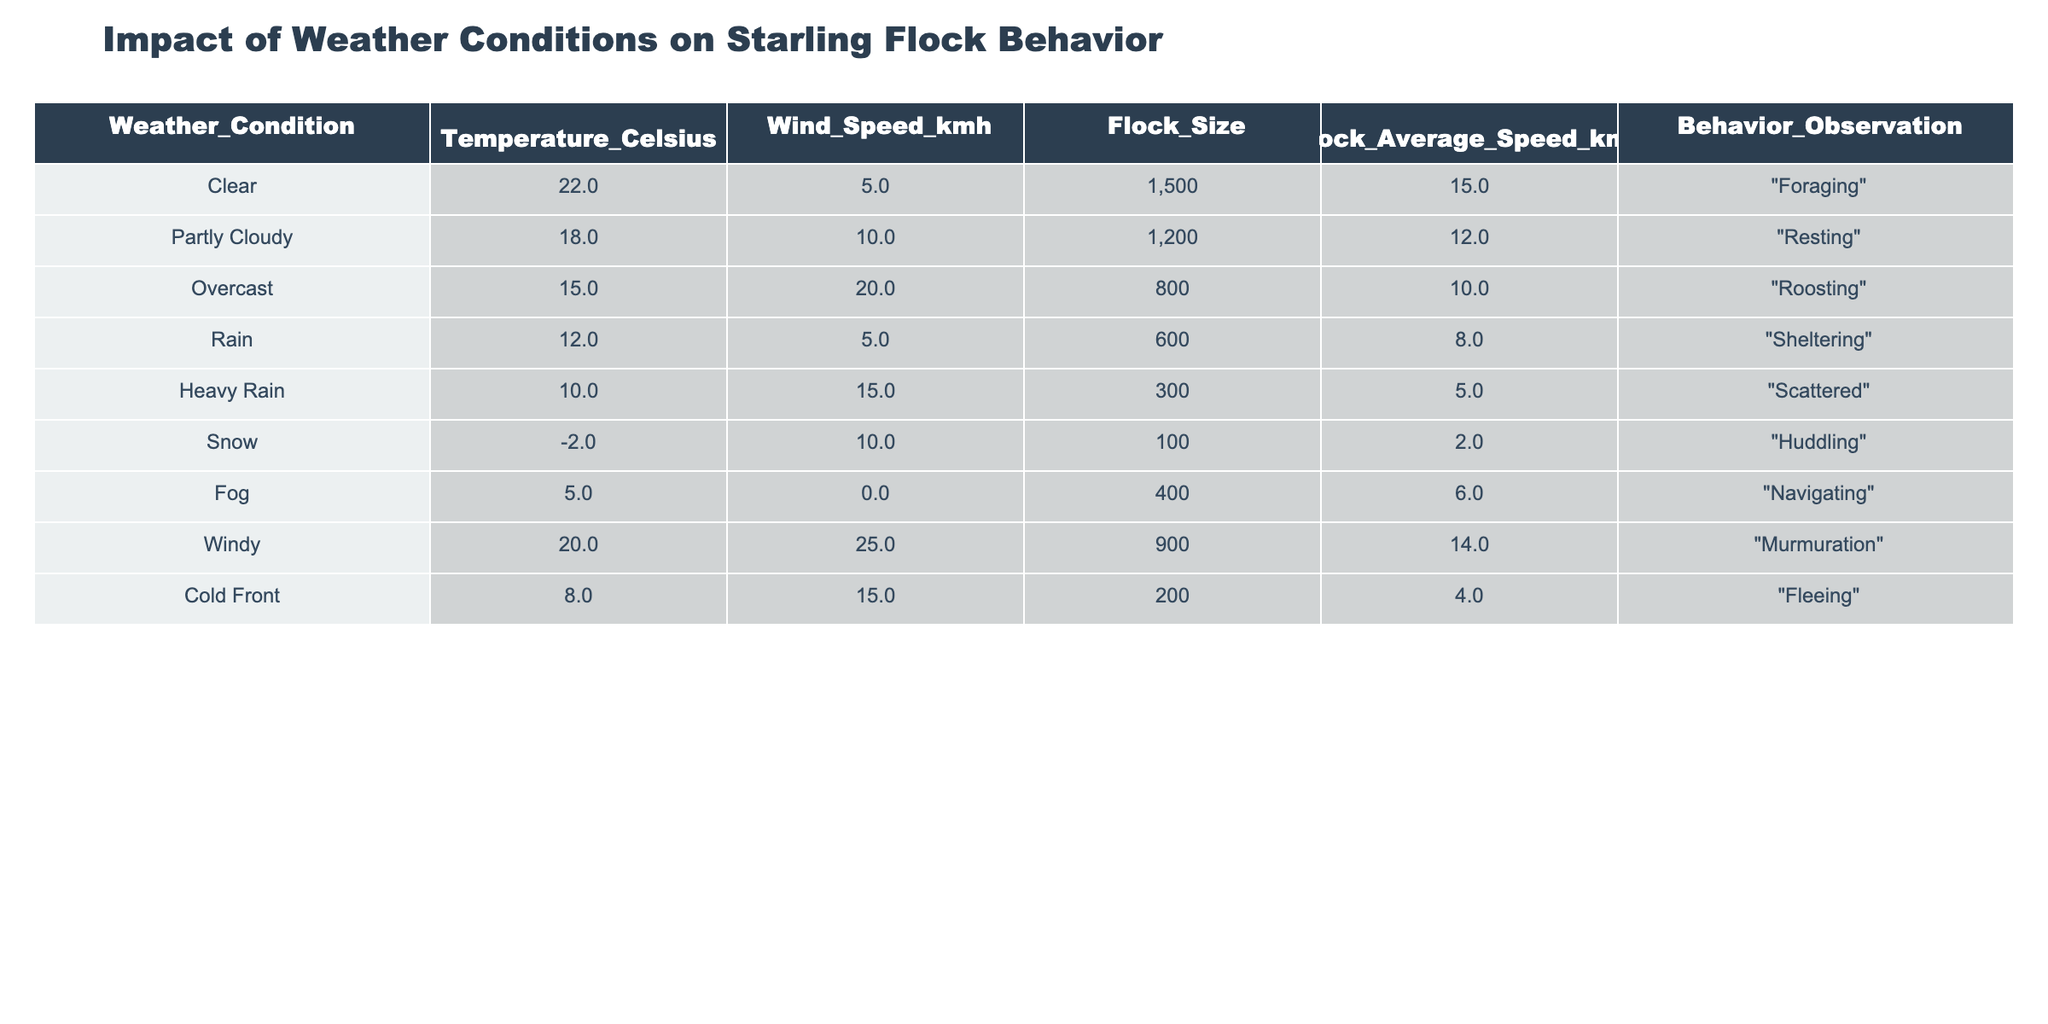What is the flock size during 'Heavy Rain'? Referring to the table, under the weather condition 'Heavy Rain', the flock size is noted as 300.
Answer: 300 What is the average temperature when the flock is 'Resting'? In the table, the temperature for the 'Resting' behavior is 18 degrees Celsius, so the average is simply 18.
Answer: 18 Is the average flock speed during 'Overcast' higher or lower than during 'Snow'? The average flock speed during 'Overcast' is 10 km/h, while during 'Snow' it is 2 km/h. Since 10 is greater than 2, the average flock speed during 'Overcast' is higher.
Answer: Higher What is the combined flock size during 'Fog' and 'Windy' weather conditions? From the table, the flock size during 'Fog' is 400, and during 'Windy' it is 900. Adding these together gives 400 + 900 = 1300.
Answer: 1300 How many weather conditions show a flock average speed of less than 6 km/h? Checking the table, only 'Snow' with a speed of 2 km/h meets this criteria, so there is 1 condition.
Answer: 1 What behavior is observed with the largest flock size, and what is that size? Looking at the table, 'Foraging' behavior has the largest flock size of 1500, which is noted under the condition 'Clear'.
Answer: Foraging, 1500 Is there any behavior that is associated with 'Cold Front'? The table states that under the weather condition 'Cold Front', the behavior observed is 'Fleeing'.
Answer: Yes, Fleeing How does the flock average speed change from 'Rain' to 'Heavy Rain'? During 'Rain', the average flock speed is 8 km/h, and during 'Heavy Rain' it is 5 km/h. The change is a decrease of 3 km/h.
Answer: Decreased by 3 km/h What is the average flock size across all weather conditions? To calculate the average flock size, we first sum the flock sizes from the table: (1500 + 1200 + 800 + 600 + 300 + 100 + 400 + 900 + 200) = 5100. There are 9 entries, making the average 5100/9 ≈ 566.67.
Answer: Approximately 566.67 Which weather condition corresponds to the highest wind speed and what is that value? The highest wind speed in the table is 25 km/h, which corresponds to the weather condition 'Windy'.
Answer: Windy, 25 km/h 